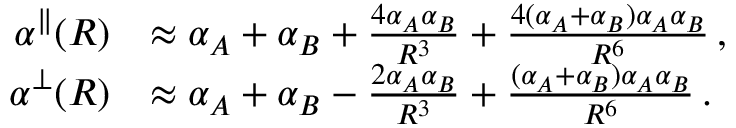Convert formula to latex. <formula><loc_0><loc_0><loc_500><loc_500>\begin{array} { r l } { \alpha ^ { \| } ( R ) } & { \approx \alpha _ { A } + \alpha _ { B } + \frac { 4 \alpha _ { A } \alpha _ { B } } { R ^ { 3 } } + \frac { 4 ( \alpha _ { A } + \alpha _ { B } ) \alpha _ { A } \alpha _ { B } } { R ^ { 6 } } \, , } \\ { \alpha ^ { \perp } ( R ) } & { \approx \alpha _ { A } + \alpha _ { B } - \frac { 2 \alpha _ { A } \alpha _ { B } } { R ^ { 3 } } + \frac { ( \alpha _ { A } + \alpha _ { B } ) \alpha _ { A } \alpha _ { B } } { R ^ { 6 } } \, . } \end{array}</formula> 